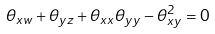<formula> <loc_0><loc_0><loc_500><loc_500>\theta _ { x w } + \theta _ { y z } + \theta _ { x x } \theta _ { y y } - \theta _ { x y } ^ { 2 } = 0</formula> 